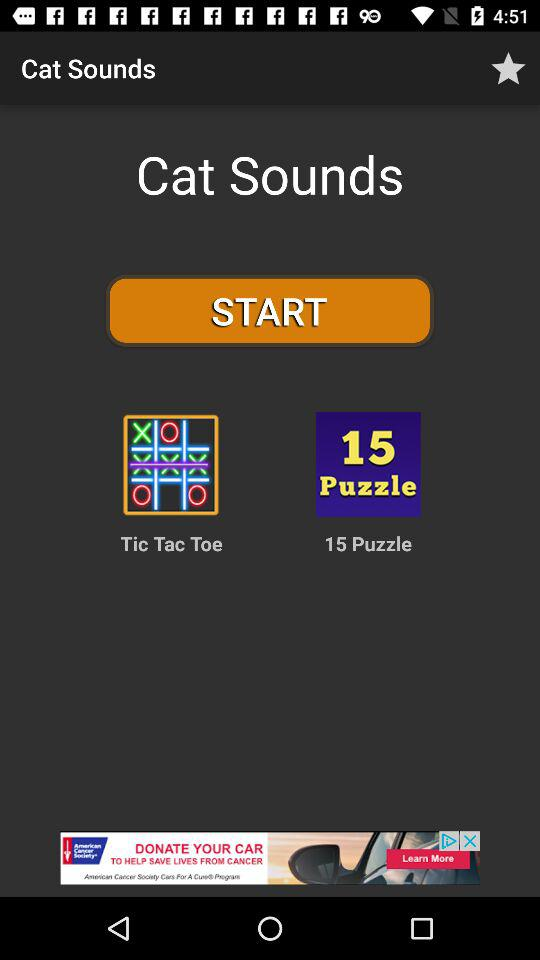What is the name of games shown here? The name of the games are "Tic Tac Toe" and "15 Puzzle". 